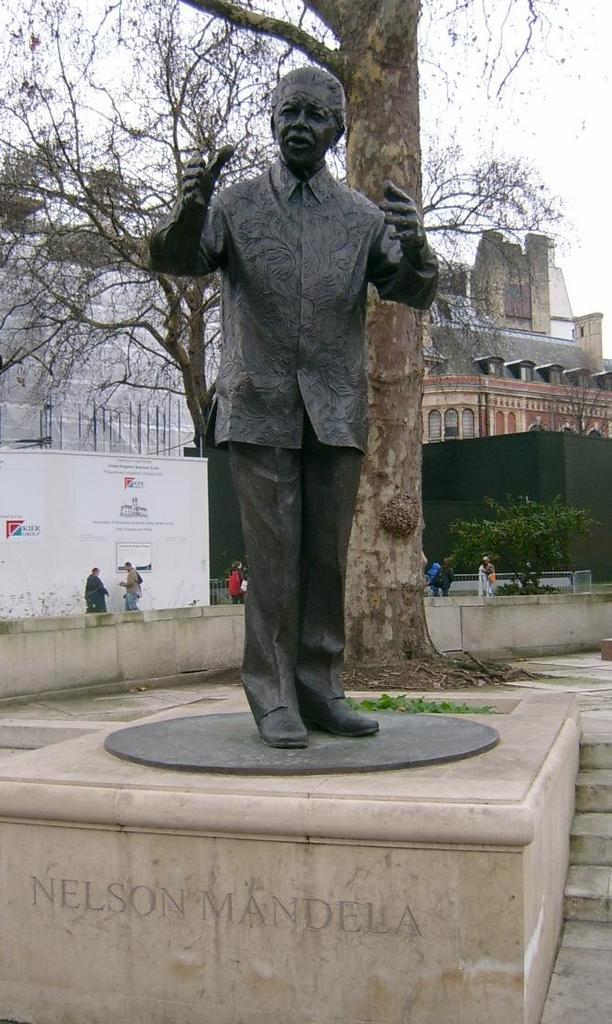What is the main subject in the image? There is a statue in the image. Are there any other subjects or objects in the image? Yes, there are people, buildings, and trees in the image. What is visible at the top of the image? The sky is visible at the top of the image. What type of baseball game is being played in the image? There is no baseball game present in the image. What color is the sheet draped over the statue in the image? There is no sheet present in the image; the statue is visible without any covering. 